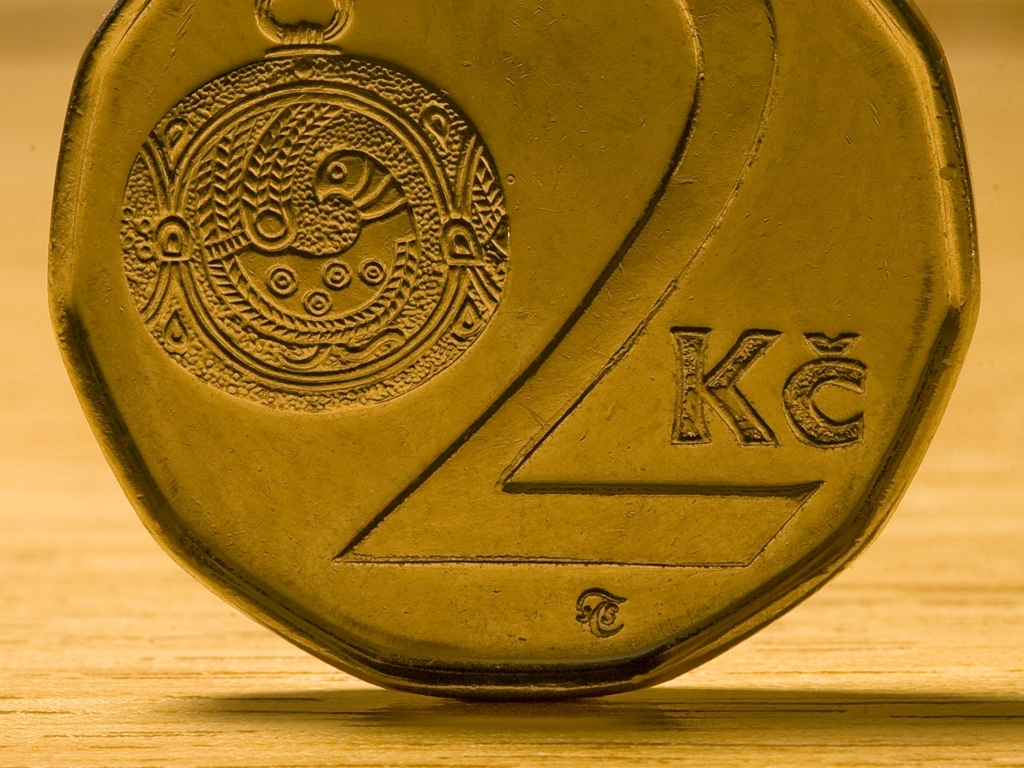What is the significance of the warm lighting in the image? The warm lighting accentuates the coin's features, creating a sense of depth and highlighting the textures. It gives the image an inviting atmosphere and can evoke emotions of nostalgia or value. This type of lighting can also suggest that the coin is being presented in a favorable light, perhaps for display, sale, or auction. How might the appearance of the coin change under different lighting conditions? Under cooler lighting, the coin's color tones would appear less yellow and more true to its material. Bright, direct lighting could lead to more pronounced shadows and highlights that reveal more texture details but may also cause glare. Diffused lighting would soften shadows and create a more even illumination, potentially making the coin's surface details less dramatic. 